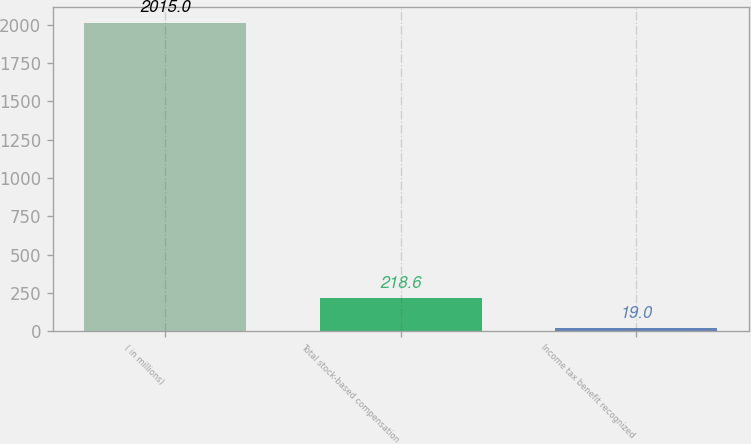Convert chart to OTSL. <chart><loc_0><loc_0><loc_500><loc_500><bar_chart><fcel>( in millions)<fcel>Total stock-based compensation<fcel>Income tax benefit recognized<nl><fcel>2015<fcel>218.6<fcel>19<nl></chart> 